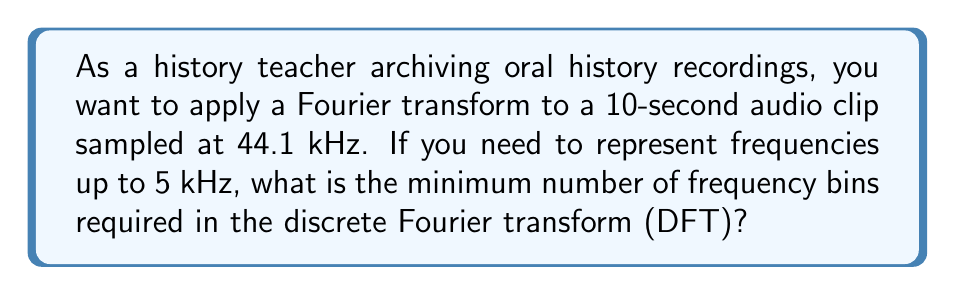What is the answer to this math problem? Let's approach this step-by-step:

1) First, we need to understand what the sampling rate means:
   44.1 kHz means 44,100 samples per second.

2) For a 10-second clip, the total number of samples is:
   $N = 44100 \times 10 = 441000$ samples

3) In the discrete Fourier transform, the frequency resolution is given by:
   $$\Delta f = \frac{f_s}{N}$$
   where $f_s$ is the sampling frequency and $N$ is the number of samples.

4) Substituting our values:
   $$\Delta f = \frac{44100}{441000} = 0.1 \text{ Hz}$$

5) The number of frequency bins up to 5 kHz would be:
   $$\text{Number of bins} = \frac{5000 \text{ Hz}}{0.1 \text{ Hz/bin}} = 50000 \text{ bins}$$

6) However, the DFT produces $N/2$ unique frequency bins (the other half are complex conjugates).

7) Therefore, the minimum number of bins in the full DFT to represent up to 5 kHz is:
   $$\text{Minimum bins} = 50000 \times 2 = 100000 \text{ bins}$$

This means we need at least 100,000 points in our DFT to represent frequencies up to 5 kHz with the given sampling rate and duration.
Answer: 100,000 bins 